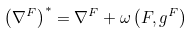<formula> <loc_0><loc_0><loc_500><loc_500>\left ( \nabla ^ { F } \right ) ^ { * } = \nabla ^ { F } + \omega \left ( F , g ^ { F } \right )</formula> 